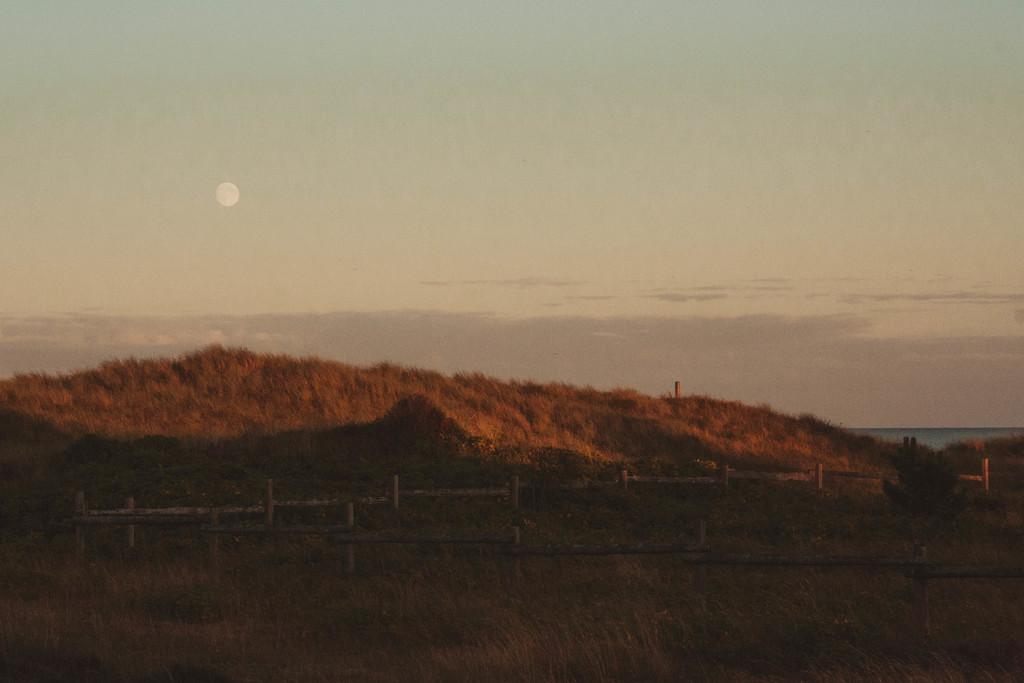What type of barrier can be seen in the image? There is a wooden fence in the image. What type of vegetation is visible in the image? There is grass visible in the image. What part of the natural environment is visible in the image? The sky is visible in the image. Can you describe the object in the sky? The object in the sky might be the moon, but this is uncertain and should not be considered a fact without further clarification. What type of punishment is being served in the image? There is no indication of punishment in the image; it features a wooden fence, grass, and an unidentified object in the sky. What type of wealth is displayed in the image? There is no indication of wealth in the image; it features a wooden fence, grass, and an unidentified object in the sky. 